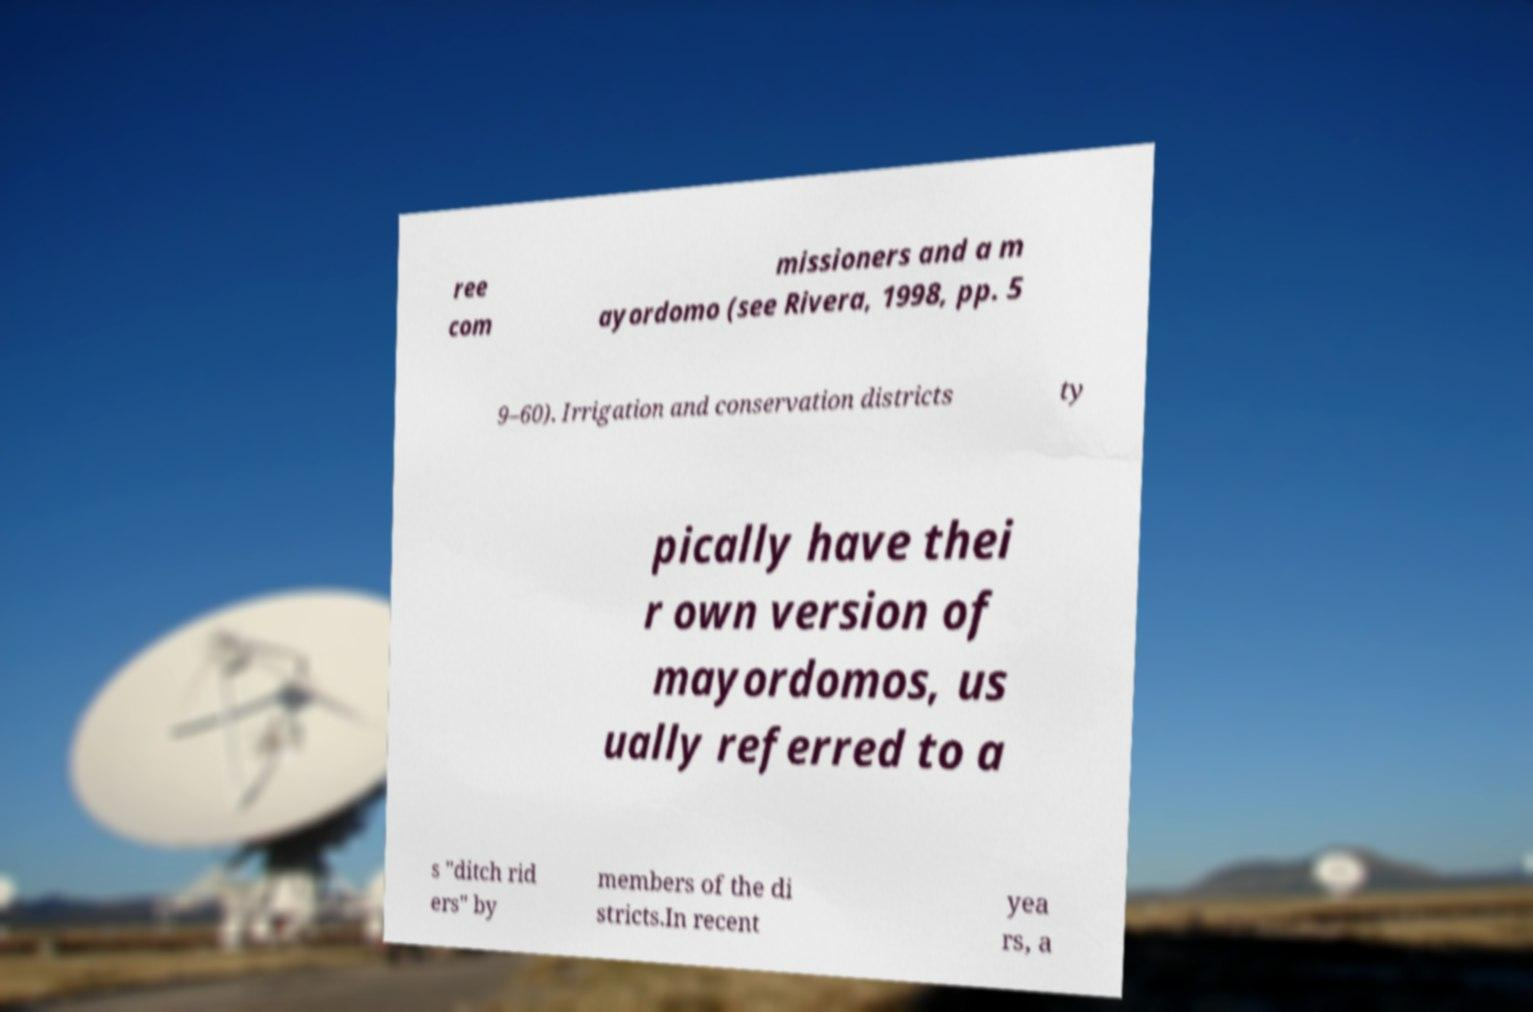Can you accurately transcribe the text from the provided image for me? ree com missioners and a m ayordomo (see Rivera, 1998, pp. 5 9–60). Irrigation and conservation districts ty pically have thei r own version of mayordomos, us ually referred to a s "ditch rid ers" by members of the di stricts.In recent yea rs, a 